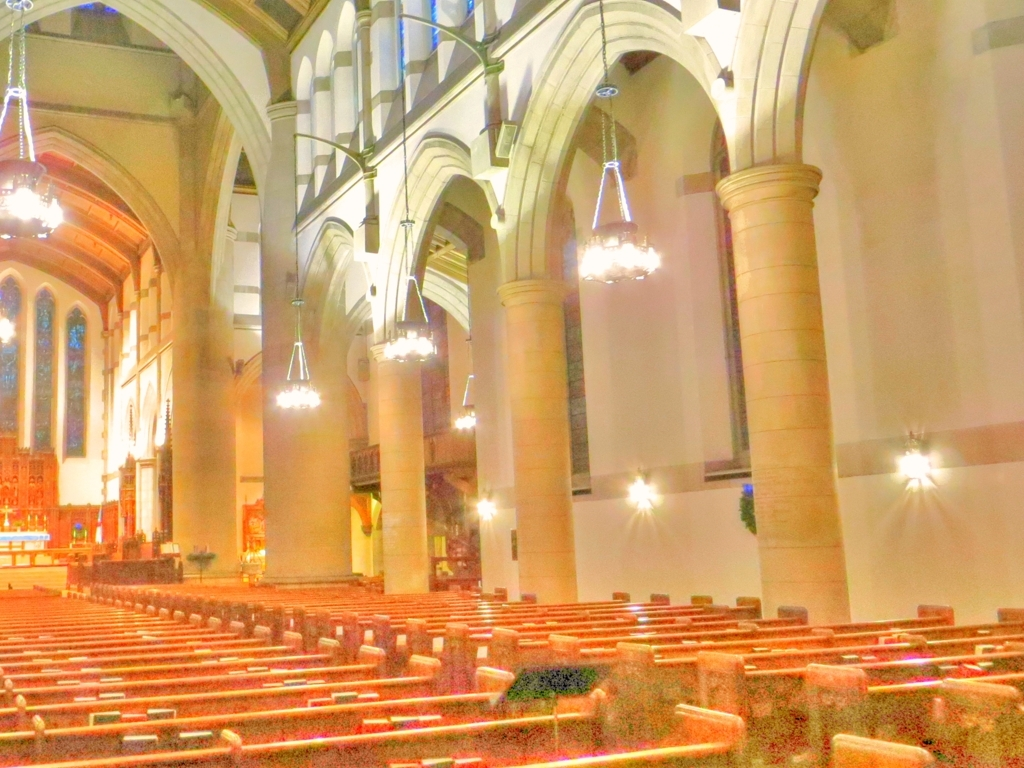Are there any quality issues with this image? Yes, the image appears to be oversaturated and overexposed in certain areas, leading to a loss of detail. The brightness levels are not balanced, giving the picture an unnatural hue and reducing the visibility of the architectural features. 